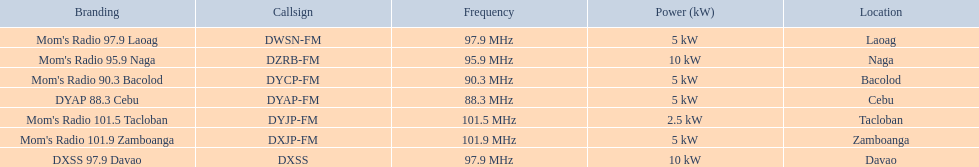What is the complete list of frequencies? 97.9 MHz, 95.9 MHz, 90.3 MHz, 88.3 MHz, 101.5 MHz, 101.9 MHz, 97.9 MHz. Among them, which one has the lowest value? 88.3 MHz. To which brand does this particular frequency belong? DYAP 88.3 Cebu. 